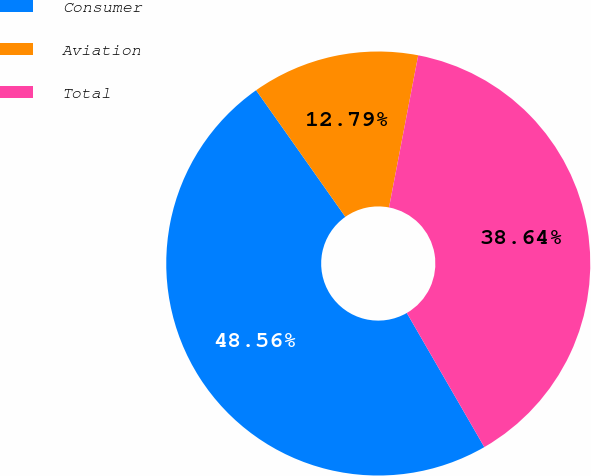Convert chart. <chart><loc_0><loc_0><loc_500><loc_500><pie_chart><fcel>Consumer<fcel>Aviation<fcel>Total<nl><fcel>48.56%<fcel>12.79%<fcel>38.64%<nl></chart> 